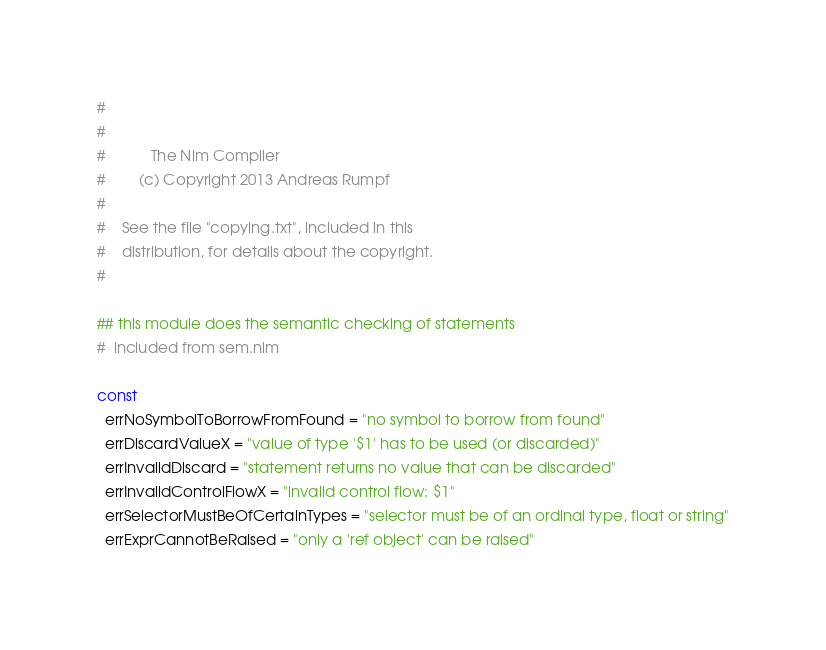<code> <loc_0><loc_0><loc_500><loc_500><_Nim_>#
#
#           The Nim Compiler
#        (c) Copyright 2013 Andreas Rumpf
#
#    See the file "copying.txt", included in this
#    distribution, for details about the copyright.
#

## this module does the semantic checking of statements
#  included from sem.nim

const
  errNoSymbolToBorrowFromFound = "no symbol to borrow from found"
  errDiscardValueX = "value of type '$1' has to be used (or discarded)"
  errInvalidDiscard = "statement returns no value that can be discarded"
  errInvalidControlFlowX = "invalid control flow: $1"
  errSelectorMustBeOfCertainTypes = "selector must be of an ordinal type, float or string"
  errExprCannotBeRaised = "only a 'ref object' can be raised"</code> 